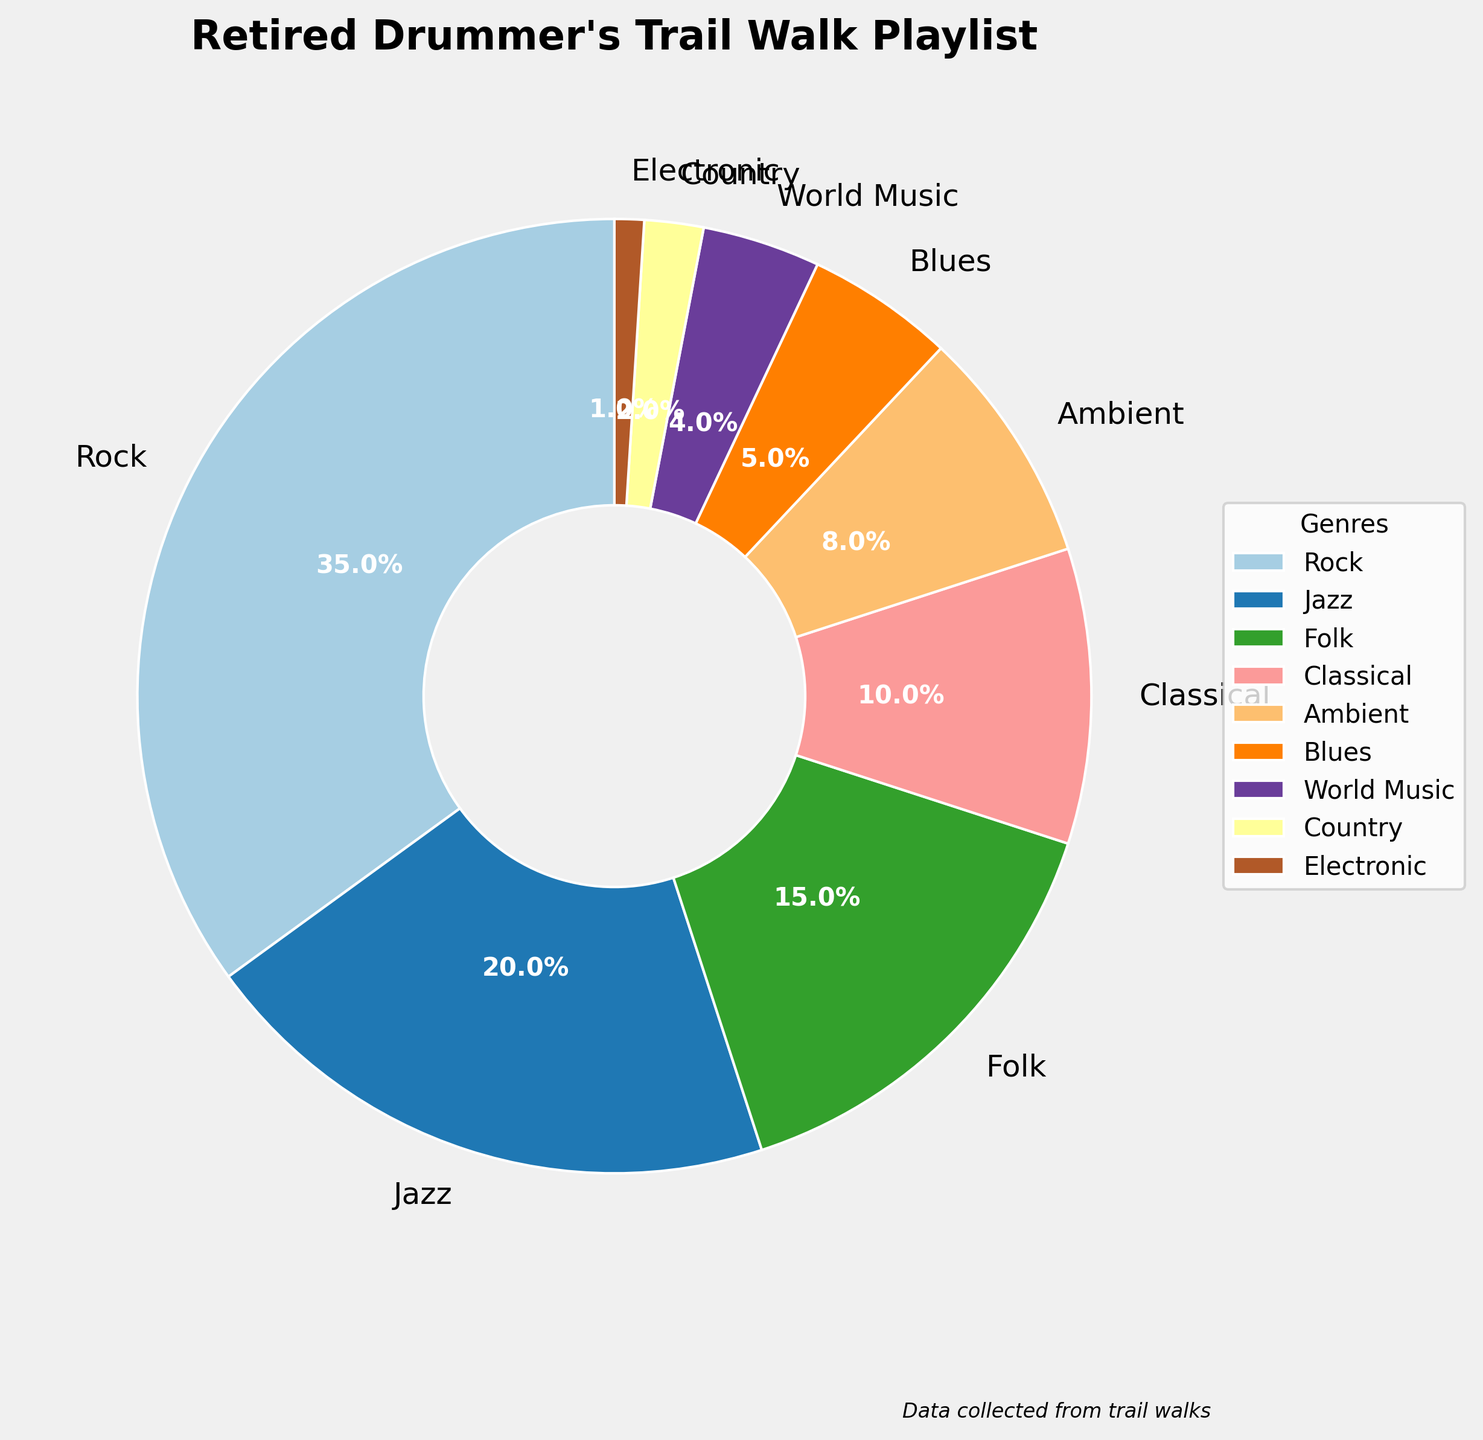What genre makes up the largest portion of the playlist? The largest portion of the playlist can be identified by looking at the slice that takes up the most space in the pie chart. Rock takes up the most space.
Answer: Rock Which two genres together make up 50% of the playlist? To find which two genres together make up 50% of the playlist, look for segments that add up to 50%. Rock (35%) and Jazz (20%) together exceed 50%, so we should consider the next largest genre. Rock (35%) and Folk (15%) together equal exactly 50%.
Answer: Rock and Folk Is the percentage of Ambient music greater than that of Blues? Compare the size of the slices representing Ambient (8%) and Blues (5%). Ambient is larger than Blues.
Answer: Yes What is the combined percentage of Classical and World Music? Add the percentages of Classical and World Music: 10% + 4% = 14%.
Answer: 14% Which genre occupies the smallest portion of the playlist? The smallest portion is identified by looking at the smallest slice in the pie chart. Electronic music has the smallest slice.
Answer: Electronic Between Jazz and Country, how much more percentage does Jazz occupy? Subtract the percentage of Country from the percentage of Jazz: 20% - 2% = 18%.
Answer: 18% How many genres make up more than 10% of the playlist each? Count the segments with percentages greater than 10%. Rock (35%) and Jazz (20%) are the only ones greater than 10%.
Answer: 2 What is the percentage difference between Folk and Ambient music? Subtract Ambient's percentage from Folk's: 15% - 8% = 7%.
Answer: 7% Name all genres that make up less than 5% of the playlist. Identify all segments that are less than 5%. These are World Music (4%), Country (2%), and Electronic (1%).
Answer: World Music, Country, and Electronic What percentage of the playlist is made up of genres other than Rock? Subtract Rock's percentage from the total 100%: 100% - 35% = 65%.
Answer: 65% 